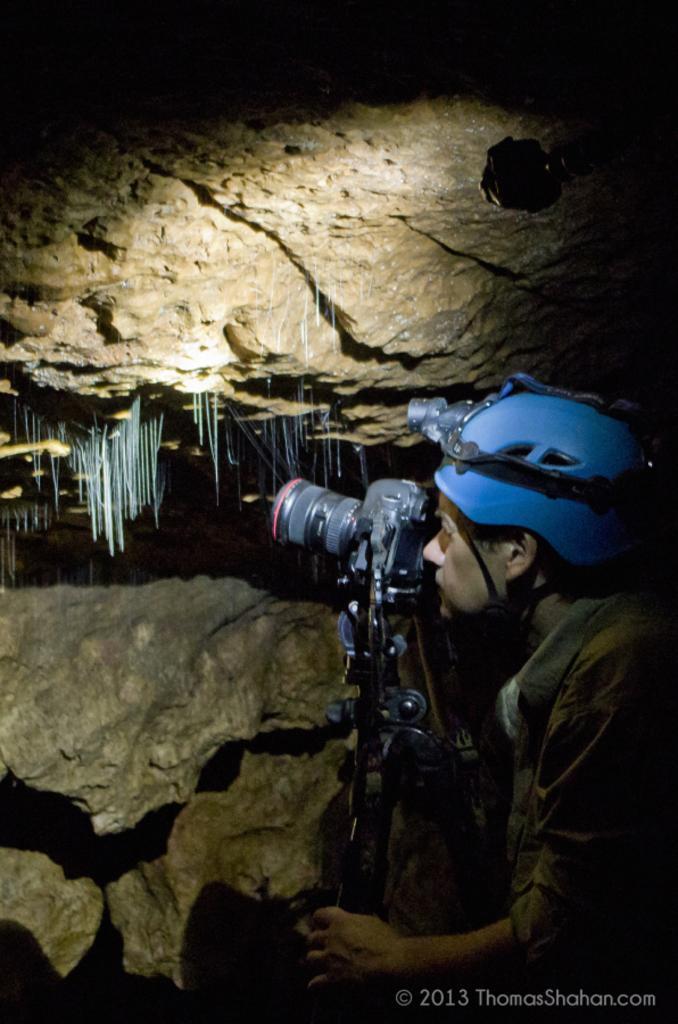How would you summarize this image in a sentence or two? This picture is taken in the dark where we can see a person wearing a helmet is standing in front of the camera which is fixed to the tripod stand. Here we can see the rocks and here we can see the watermark on the bottom right side of the image. 